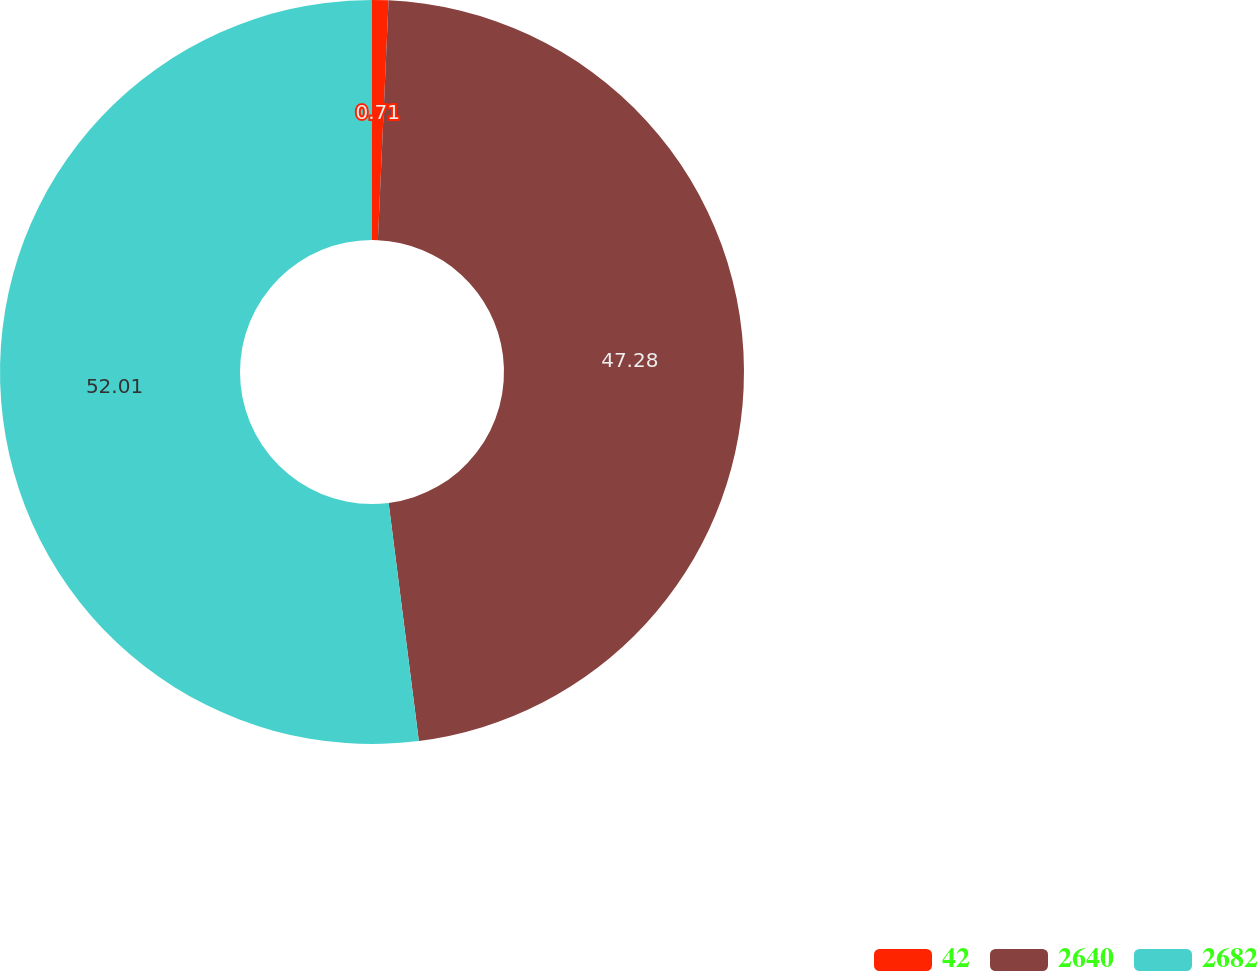Convert chart. <chart><loc_0><loc_0><loc_500><loc_500><pie_chart><fcel>42<fcel>2640<fcel>2682<nl><fcel>0.71%<fcel>47.28%<fcel>52.01%<nl></chart> 